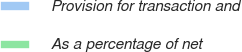Convert chart. <chart><loc_0><loc_0><loc_500><loc_500><pie_chart><fcel>Provision for transaction and<fcel>As a percentage of net<nl><fcel>100.0%<fcel>0.0%<nl></chart> 